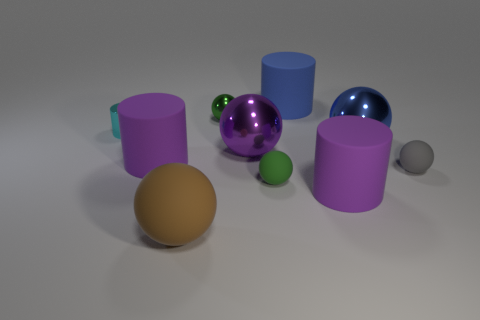What number of other objects are the same material as the small cyan object?
Ensure brevity in your answer.  3. Is there a ball that is in front of the big purple matte cylinder that is behind the gray rubber sphere?
Make the answer very short. Yes. Are there any other things that are the same shape as the gray matte thing?
Keep it short and to the point. Yes. There is a small metal thing that is the same shape as the large brown matte thing; what color is it?
Ensure brevity in your answer.  Green. What size is the blue rubber thing?
Keep it short and to the point. Large. Are there fewer matte balls that are left of the big blue sphere than cyan things?
Offer a terse response. No. Do the brown sphere and the small ball that is in front of the tiny gray rubber thing have the same material?
Keep it short and to the point. Yes. There is a blue object in front of the green thing on the left side of the green rubber thing; are there any purple balls on the right side of it?
Ensure brevity in your answer.  No. Are there any other things that are the same size as the blue shiny sphere?
Give a very brief answer. Yes. There is another large ball that is made of the same material as the purple sphere; what color is it?
Your answer should be very brief. Blue. 